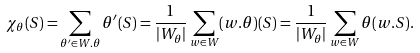<formula> <loc_0><loc_0><loc_500><loc_500>\chi _ { \theta } ( S ) = \sum _ { \theta ^ { \prime } \in W . \theta } \theta ^ { \prime } ( S ) = \frac { 1 } { | W _ { \theta } | } \sum _ { w \in W } ( w . \theta ) ( S ) = \frac { 1 } { | W _ { \theta } | } \sum _ { w \in W } \theta ( w . S ) .</formula> 